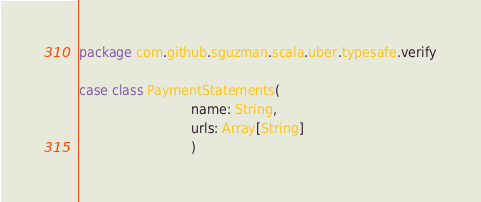<code> <loc_0><loc_0><loc_500><loc_500><_Scala_>package com.github.sguzman.scala.uber.typesafe.verify

case class PaymentStatements(
                            name: String,
                            urls: Array[String]
                            )
</code> 